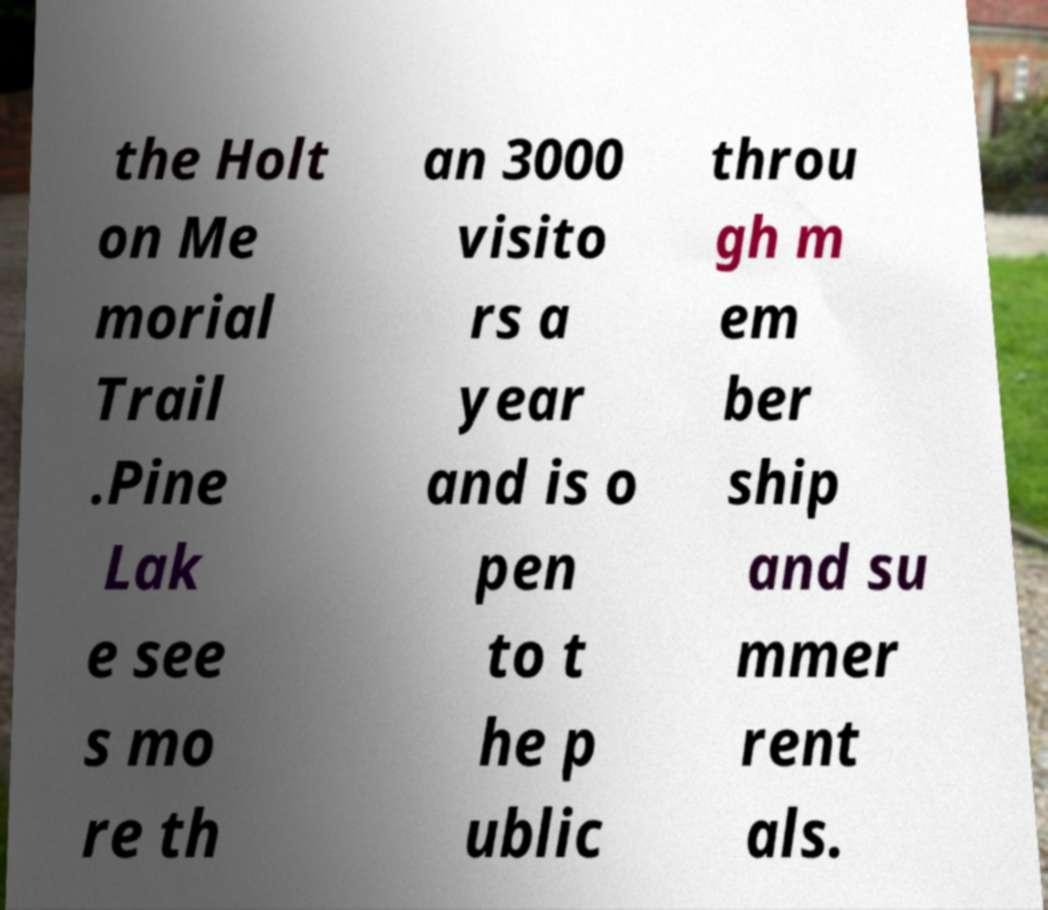Could you assist in decoding the text presented in this image and type it out clearly? the Holt on Me morial Trail .Pine Lak e see s mo re th an 3000 visito rs a year and is o pen to t he p ublic throu gh m em ber ship and su mmer rent als. 